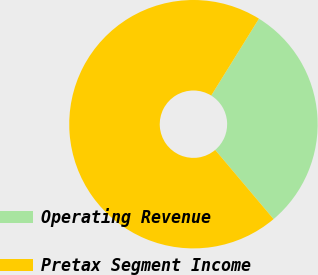Convert chart to OTSL. <chart><loc_0><loc_0><loc_500><loc_500><pie_chart><fcel>Operating Revenue<fcel>Pretax Segment Income<nl><fcel>30.0%<fcel>70.0%<nl></chart> 